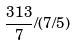Convert formula to latex. <formula><loc_0><loc_0><loc_500><loc_500>\frac { 3 1 3 } { 7 } / ( 7 / 5 )</formula> 